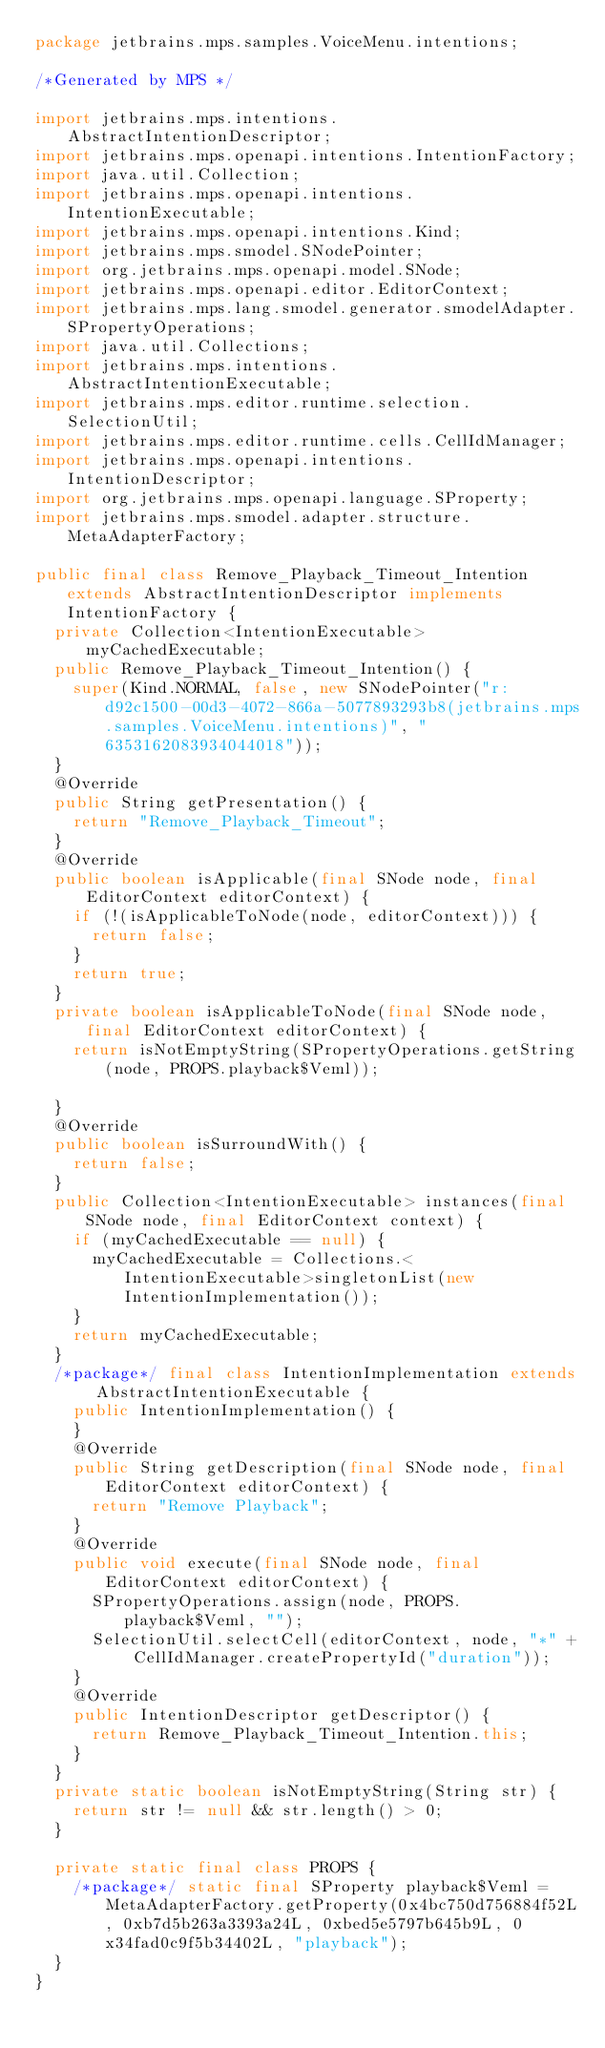<code> <loc_0><loc_0><loc_500><loc_500><_Java_>package jetbrains.mps.samples.VoiceMenu.intentions;

/*Generated by MPS */

import jetbrains.mps.intentions.AbstractIntentionDescriptor;
import jetbrains.mps.openapi.intentions.IntentionFactory;
import java.util.Collection;
import jetbrains.mps.openapi.intentions.IntentionExecutable;
import jetbrains.mps.openapi.intentions.Kind;
import jetbrains.mps.smodel.SNodePointer;
import org.jetbrains.mps.openapi.model.SNode;
import jetbrains.mps.openapi.editor.EditorContext;
import jetbrains.mps.lang.smodel.generator.smodelAdapter.SPropertyOperations;
import java.util.Collections;
import jetbrains.mps.intentions.AbstractIntentionExecutable;
import jetbrains.mps.editor.runtime.selection.SelectionUtil;
import jetbrains.mps.editor.runtime.cells.CellIdManager;
import jetbrains.mps.openapi.intentions.IntentionDescriptor;
import org.jetbrains.mps.openapi.language.SProperty;
import jetbrains.mps.smodel.adapter.structure.MetaAdapterFactory;

public final class Remove_Playback_Timeout_Intention extends AbstractIntentionDescriptor implements IntentionFactory {
  private Collection<IntentionExecutable> myCachedExecutable;
  public Remove_Playback_Timeout_Intention() {
    super(Kind.NORMAL, false, new SNodePointer("r:d92c1500-00d3-4072-866a-5077893293b8(jetbrains.mps.samples.VoiceMenu.intentions)", "6353162083934044018"));
  }
  @Override
  public String getPresentation() {
    return "Remove_Playback_Timeout";
  }
  @Override
  public boolean isApplicable(final SNode node, final EditorContext editorContext) {
    if (!(isApplicableToNode(node, editorContext))) {
      return false;
    }
    return true;
  }
  private boolean isApplicableToNode(final SNode node, final EditorContext editorContext) {
    return isNotEmptyString(SPropertyOperations.getString(node, PROPS.playback$Veml));

  }
  @Override
  public boolean isSurroundWith() {
    return false;
  }
  public Collection<IntentionExecutable> instances(final SNode node, final EditorContext context) {
    if (myCachedExecutable == null) {
      myCachedExecutable = Collections.<IntentionExecutable>singletonList(new IntentionImplementation());
    }
    return myCachedExecutable;
  }
  /*package*/ final class IntentionImplementation extends AbstractIntentionExecutable {
    public IntentionImplementation() {
    }
    @Override
    public String getDescription(final SNode node, final EditorContext editorContext) {
      return "Remove Playback";
    }
    @Override
    public void execute(final SNode node, final EditorContext editorContext) {
      SPropertyOperations.assign(node, PROPS.playback$Veml, "");
      SelectionUtil.selectCell(editorContext, node, "*" + CellIdManager.createPropertyId("duration"));
    }
    @Override
    public IntentionDescriptor getDescriptor() {
      return Remove_Playback_Timeout_Intention.this;
    }
  }
  private static boolean isNotEmptyString(String str) {
    return str != null && str.length() > 0;
  }

  private static final class PROPS {
    /*package*/ static final SProperty playback$Veml = MetaAdapterFactory.getProperty(0x4bc750d756884f52L, 0xb7d5b263a3393a24L, 0xbed5e5797b645b9L, 0x34fad0c9f5b34402L, "playback");
  }
}
</code> 